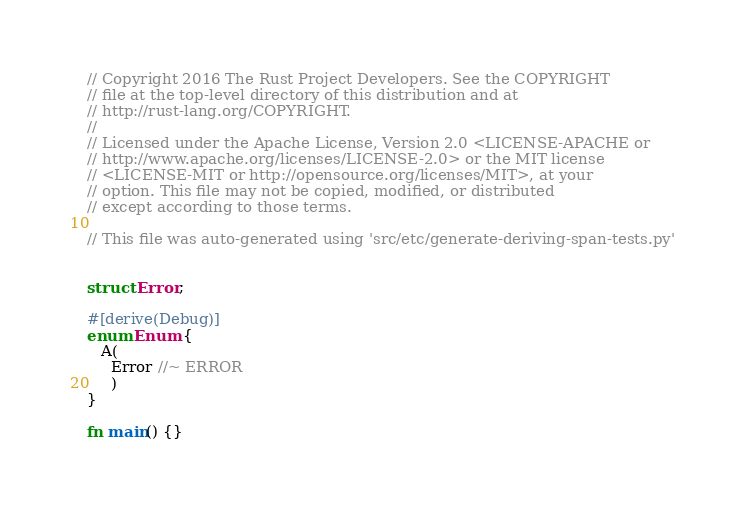<code> <loc_0><loc_0><loc_500><loc_500><_Rust_>// Copyright 2016 The Rust Project Developers. See the COPYRIGHT
// file at the top-level directory of this distribution and at
// http://rust-lang.org/COPYRIGHT.
//
// Licensed under the Apache License, Version 2.0 <LICENSE-APACHE or
// http://www.apache.org/licenses/LICENSE-2.0> or the MIT license
// <LICENSE-MIT or http://opensource.org/licenses/MIT>, at your
// option. This file may not be copied, modified, or distributed
// except according to those terms.

// This file was auto-generated using 'src/etc/generate-deriving-span-tests.py'


struct Error;

#[derive(Debug)]
enum Enum {
   A(
     Error //~ ERROR
     )
}

fn main() {}
</code> 